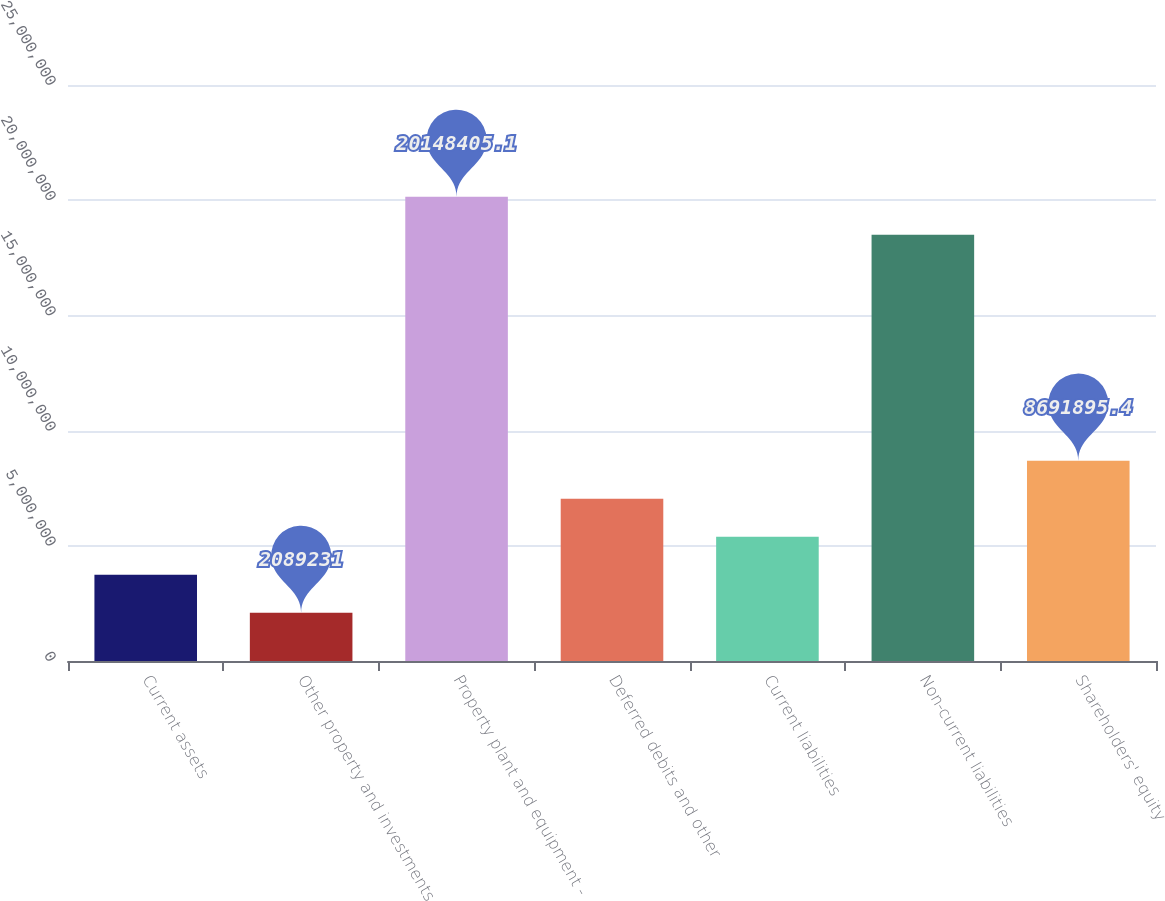Convert chart to OTSL. <chart><loc_0><loc_0><loc_500><loc_500><bar_chart><fcel>Current assets<fcel>Other property and investments<fcel>Property plant and equipment -<fcel>Deferred debits and other<fcel>Current liabilities<fcel>Non-current liabilities<fcel>Shareholders' equity<nl><fcel>3.7399e+06<fcel>2.08923e+06<fcel>2.01484e+07<fcel>7.04123e+06<fcel>5.39056e+06<fcel>1.84977e+07<fcel>8.6919e+06<nl></chart> 